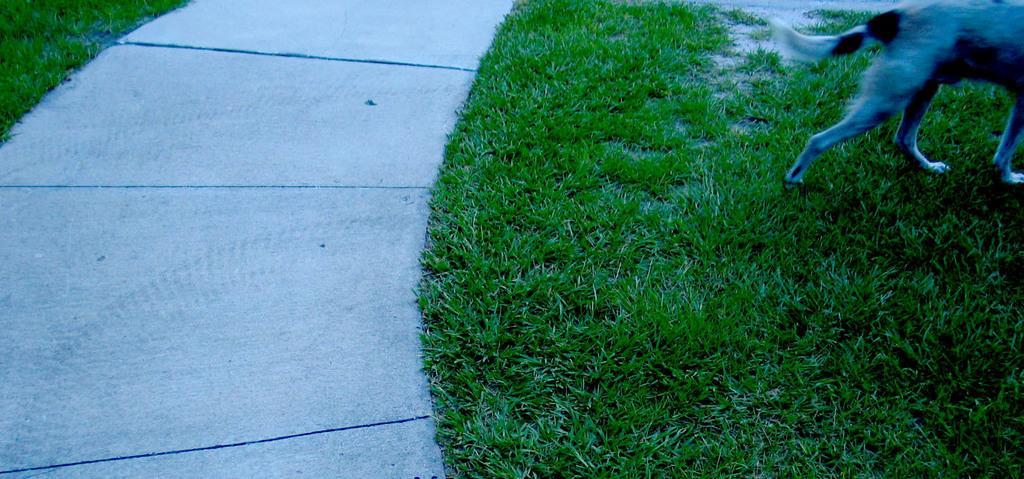Could you give a brief overview of what you see in this image? In this picture we can see a dog at the right top of the picture, at the bottom there is grass. 